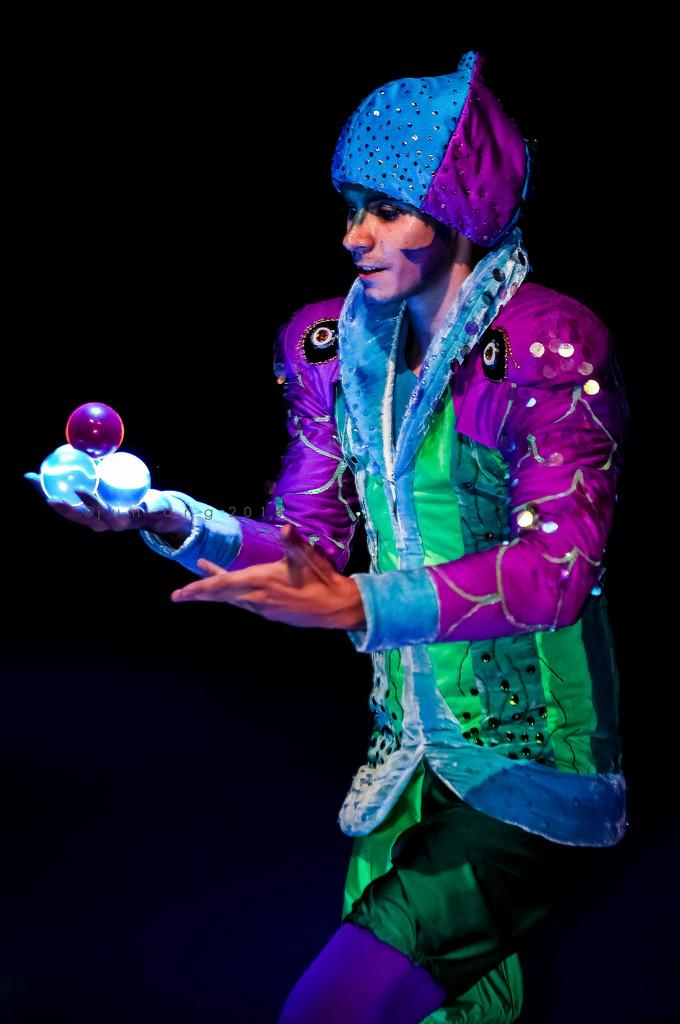What is the main subject of the image? There is a person standing in the image. What is the person holding in the image? The person is holding three balls. Can you describe the person's attire? The person is wearing a colorful costume. What is the color of the background in the image? The background of the image is black. What type of gate is visible in the image? There is no gate present in the image. 